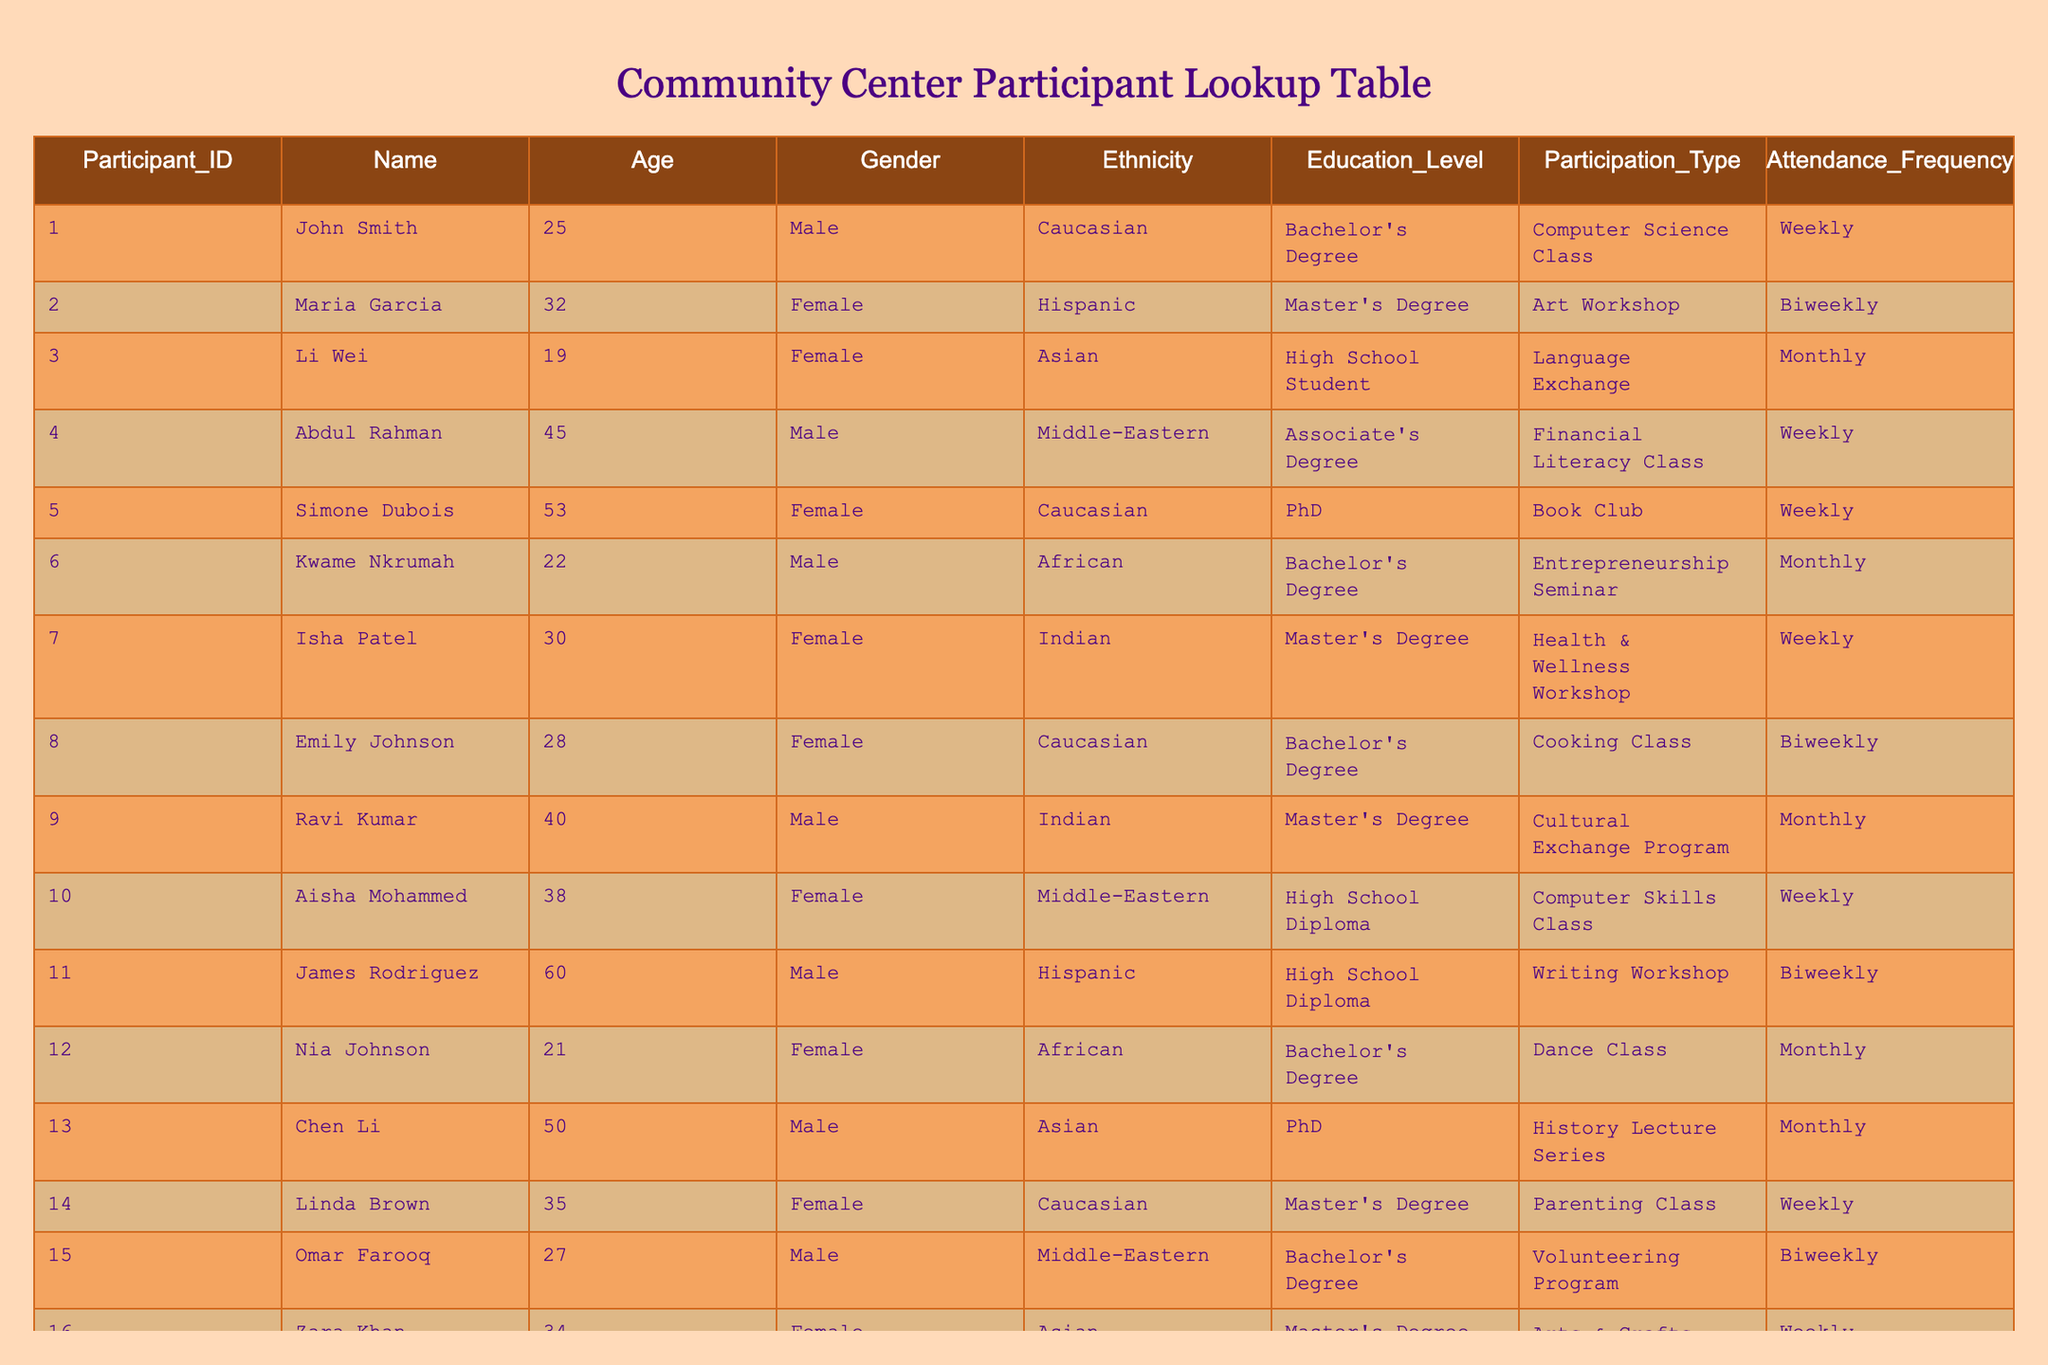What is the highest education level obtained by a participant? The education levels listed are: High School Diploma, Associate's Degree, Bachelor's Degree, Master's Degree, and PhD. The highest level in this list is PhD, which is held by Simone Dubois and Chen Li.
Answer: PhD How many participants are attending a class on a weekly basis? From the table, the participants attending weekly are: John Smith, Abdul Rahman, Simone Dubois, Isha Patel, Aisha Mohammed, Linda Brown, Zara Khan, Chloe White, giving us a total of 8 participants.
Answer: 8 What is the average age of participants with a Master's Degree? The ages of participants with a Master's Degree are 32 (Maria Garcia), 30 (Isha Patel), 35 (Linda Brown), and 40 (Ravi Kumar). Adding these ages gives us 32 + 30 + 35 + 40 = 137. Since there are 4 participants, the average age is 137 / 4 = 34.25.
Answer: 34.25 Is there a participant with both a Bachelor's Degree and attends the Cooking Class? Referring to the table, Emily Johnson holds a Bachelor's Degree and is attending the Cooking Class, confirming that this fact is true.
Answer: Yes How many male participants are under the age of 30? The male participants listed are John Smith (25), Abdul Rahman (45), Kwame Nkrumah (22), Ravi Kumar (40), Aaron Lewis (29). Among these, only John Smith and Kwame Nkrumah are under 30. Therefore, the count is 2 male participants.
Answer: 2 What are the different participation types in which Hispanic participants are involved? The Hispanic participants are Maria Garcia (Art Workshop), James Rodriguez (Writing Workshop), and Aisha Mohammed (Computer Skills Class). The unique participation types are Art Workshop, Writing Workshop, and Computer Skills Class, totaling to 3 participation types.
Answer: 3 participation types Which gender has more participants attending Language Exchange? The table indicates that Li Wei is the only participant attending the Language Exchange and is female. As there is no male participant listed for this type, the gender with the most participants is female.
Answer: Female How many participants are of African descent and what is their attendance frequency? The participants of African descent identified are Kwame Nkrumah (Monthly), Nia Johnson (Monthly), and Dylan Taylor (Biweekly). This gives us a total of 3 participants, with attendance frequencies of Monthly, Monthly, and Biweekly.
Answer: 3 participants, Monthly, Monthly, Biweekly 